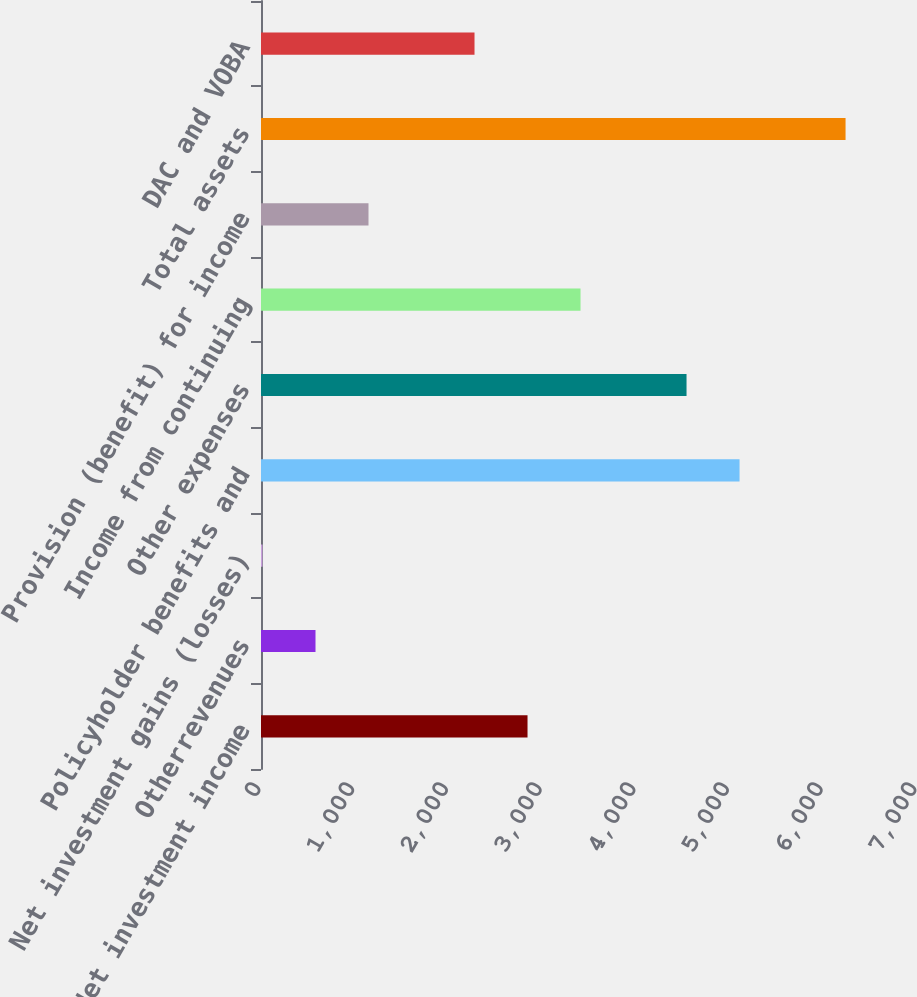<chart> <loc_0><loc_0><loc_500><loc_500><bar_chart><fcel>Net investment income<fcel>Otherrevenues<fcel>Net investment gains (losses)<fcel>Policyholder benefits and<fcel>Other expenses<fcel>Income from continuing<fcel>Provision (benefit) for income<fcel>Total assets<fcel>DAC and VOBA<nl><fcel>2844<fcel>581.6<fcel>16<fcel>5106.4<fcel>4540.8<fcel>3409.6<fcel>1147.2<fcel>6237.6<fcel>2278.4<nl></chart> 